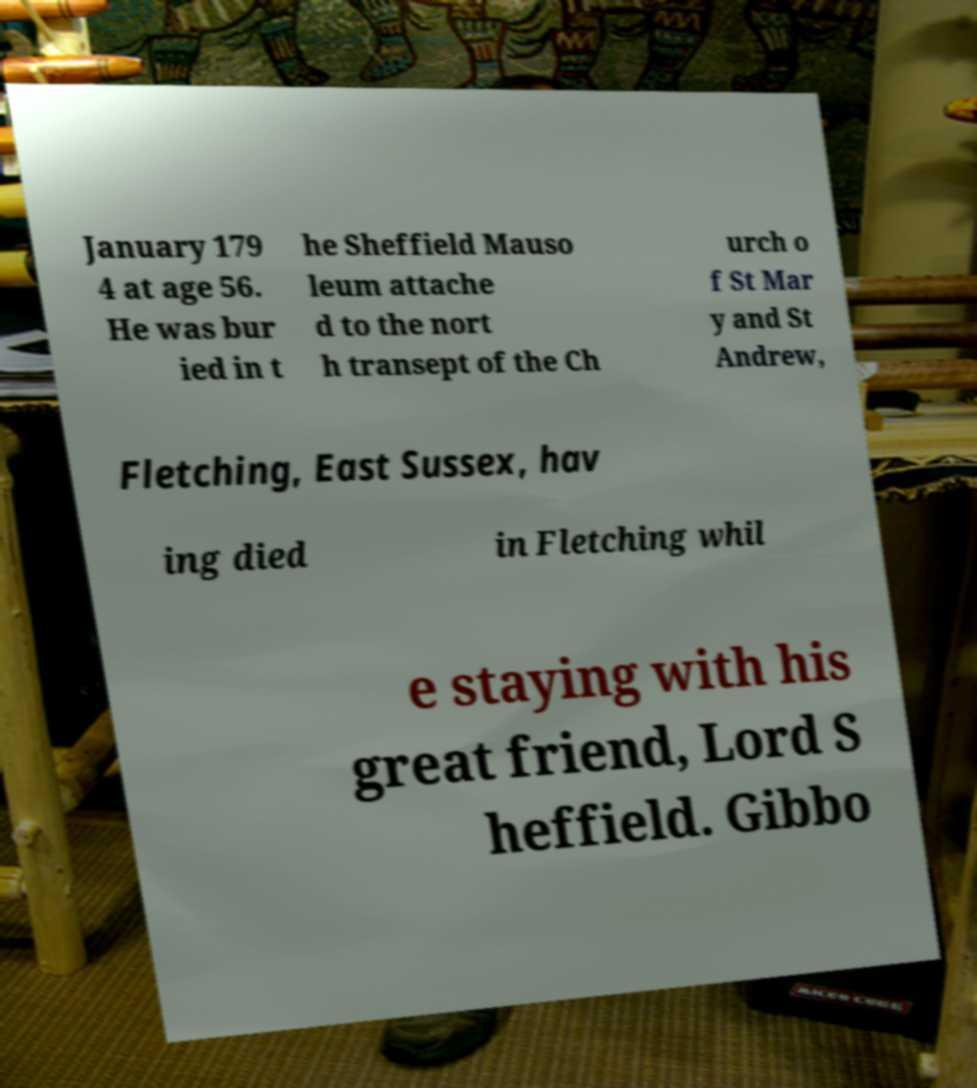Please read and relay the text visible in this image. What does it say? January 179 4 at age 56. He was bur ied in t he Sheffield Mauso leum attache d to the nort h transept of the Ch urch o f St Mar y and St Andrew, Fletching, East Sussex, hav ing died in Fletching whil e staying with his great friend, Lord S heffield. Gibbo 